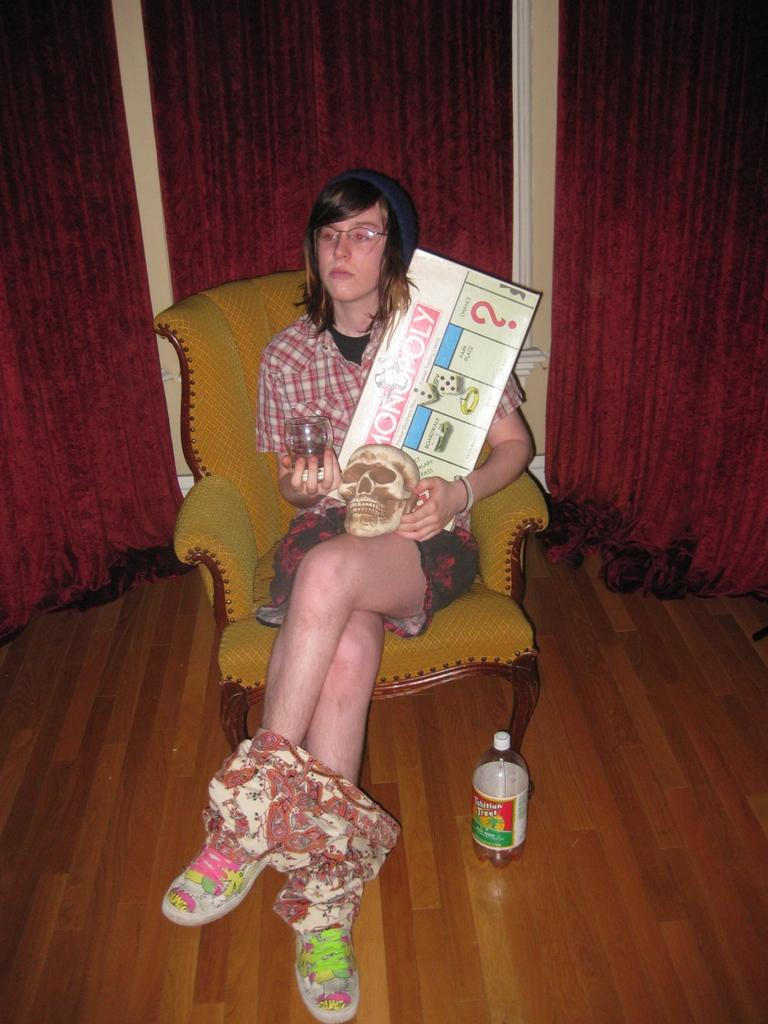Who is the main subject in the image? There is a woman in the image. What is the woman doing in the image? The woman is sitting on a chair. What objects is the woman holding in the image? The woman is holding a skull, a glass, and a paper. What is on the floor in front of the woman? There is a bottle on the floor in front of the woman. Reasoning: Let' Let's think step by step in order to produce the conversation. We start by identifying the main subject in the image, which is the woman. Then, we describe her actions and the objects she is holding. Finally, we mention the additional object on the floor in front of her. Each question is designed to elicit a specific detail about the image that is known from the provided facts. Absurd Question/Answer: What street is the woman observing in the image? There is no street visible in the image; it is focused on the woman and the objects around her. Can you tell me how many times the woman turns around in the image? There is no indication of the woman turning around in the image; she is sitting on a chair holding various objects. 